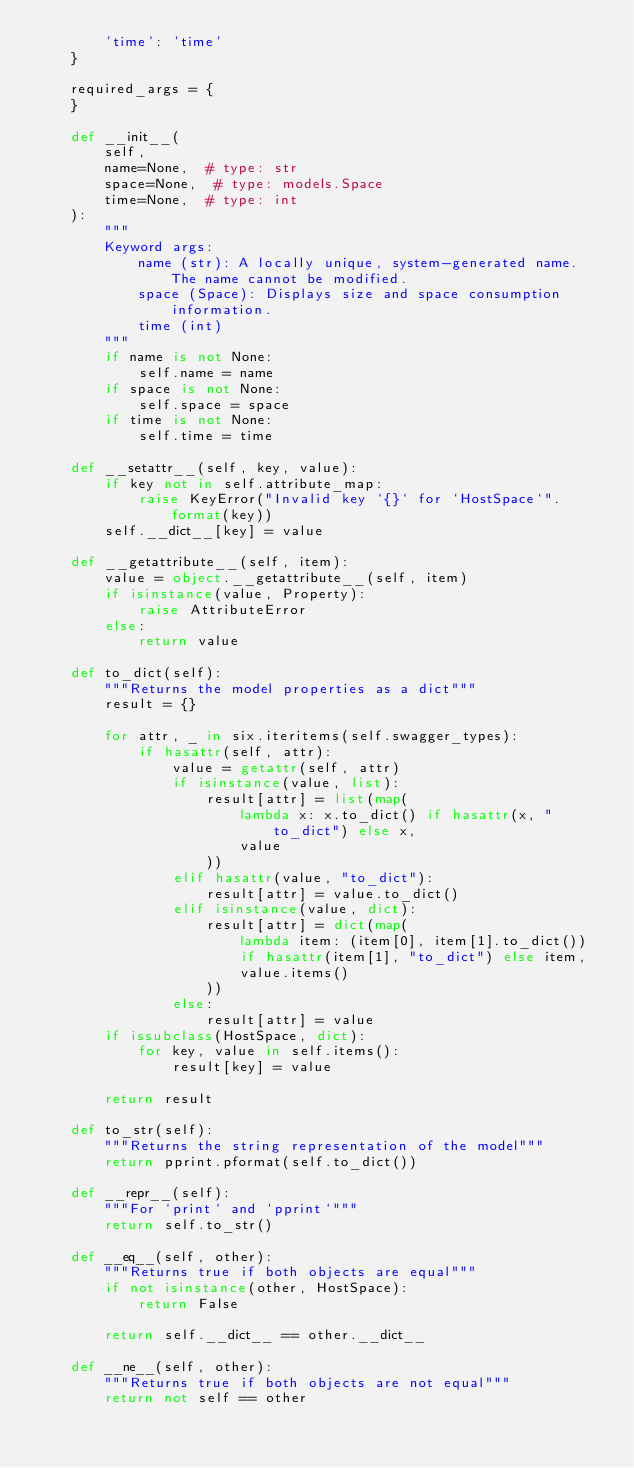<code> <loc_0><loc_0><loc_500><loc_500><_Python_>        'time': 'time'
    }

    required_args = {
    }

    def __init__(
        self,
        name=None,  # type: str
        space=None,  # type: models.Space
        time=None,  # type: int
    ):
        """
        Keyword args:
            name (str): A locally unique, system-generated name. The name cannot be modified.
            space (Space): Displays size and space consumption information.
            time (int)
        """
        if name is not None:
            self.name = name
        if space is not None:
            self.space = space
        if time is not None:
            self.time = time

    def __setattr__(self, key, value):
        if key not in self.attribute_map:
            raise KeyError("Invalid key `{}` for `HostSpace`".format(key))
        self.__dict__[key] = value

    def __getattribute__(self, item):
        value = object.__getattribute__(self, item)
        if isinstance(value, Property):
            raise AttributeError
        else:
            return value

    def to_dict(self):
        """Returns the model properties as a dict"""
        result = {}

        for attr, _ in six.iteritems(self.swagger_types):
            if hasattr(self, attr):
                value = getattr(self, attr)
                if isinstance(value, list):
                    result[attr] = list(map(
                        lambda x: x.to_dict() if hasattr(x, "to_dict") else x,
                        value
                    ))
                elif hasattr(value, "to_dict"):
                    result[attr] = value.to_dict()
                elif isinstance(value, dict):
                    result[attr] = dict(map(
                        lambda item: (item[0], item[1].to_dict())
                        if hasattr(item[1], "to_dict") else item,
                        value.items()
                    ))
                else:
                    result[attr] = value
        if issubclass(HostSpace, dict):
            for key, value in self.items():
                result[key] = value

        return result

    def to_str(self):
        """Returns the string representation of the model"""
        return pprint.pformat(self.to_dict())

    def __repr__(self):
        """For `print` and `pprint`"""
        return self.to_str()

    def __eq__(self, other):
        """Returns true if both objects are equal"""
        if not isinstance(other, HostSpace):
            return False

        return self.__dict__ == other.__dict__

    def __ne__(self, other):
        """Returns true if both objects are not equal"""
        return not self == other
</code> 